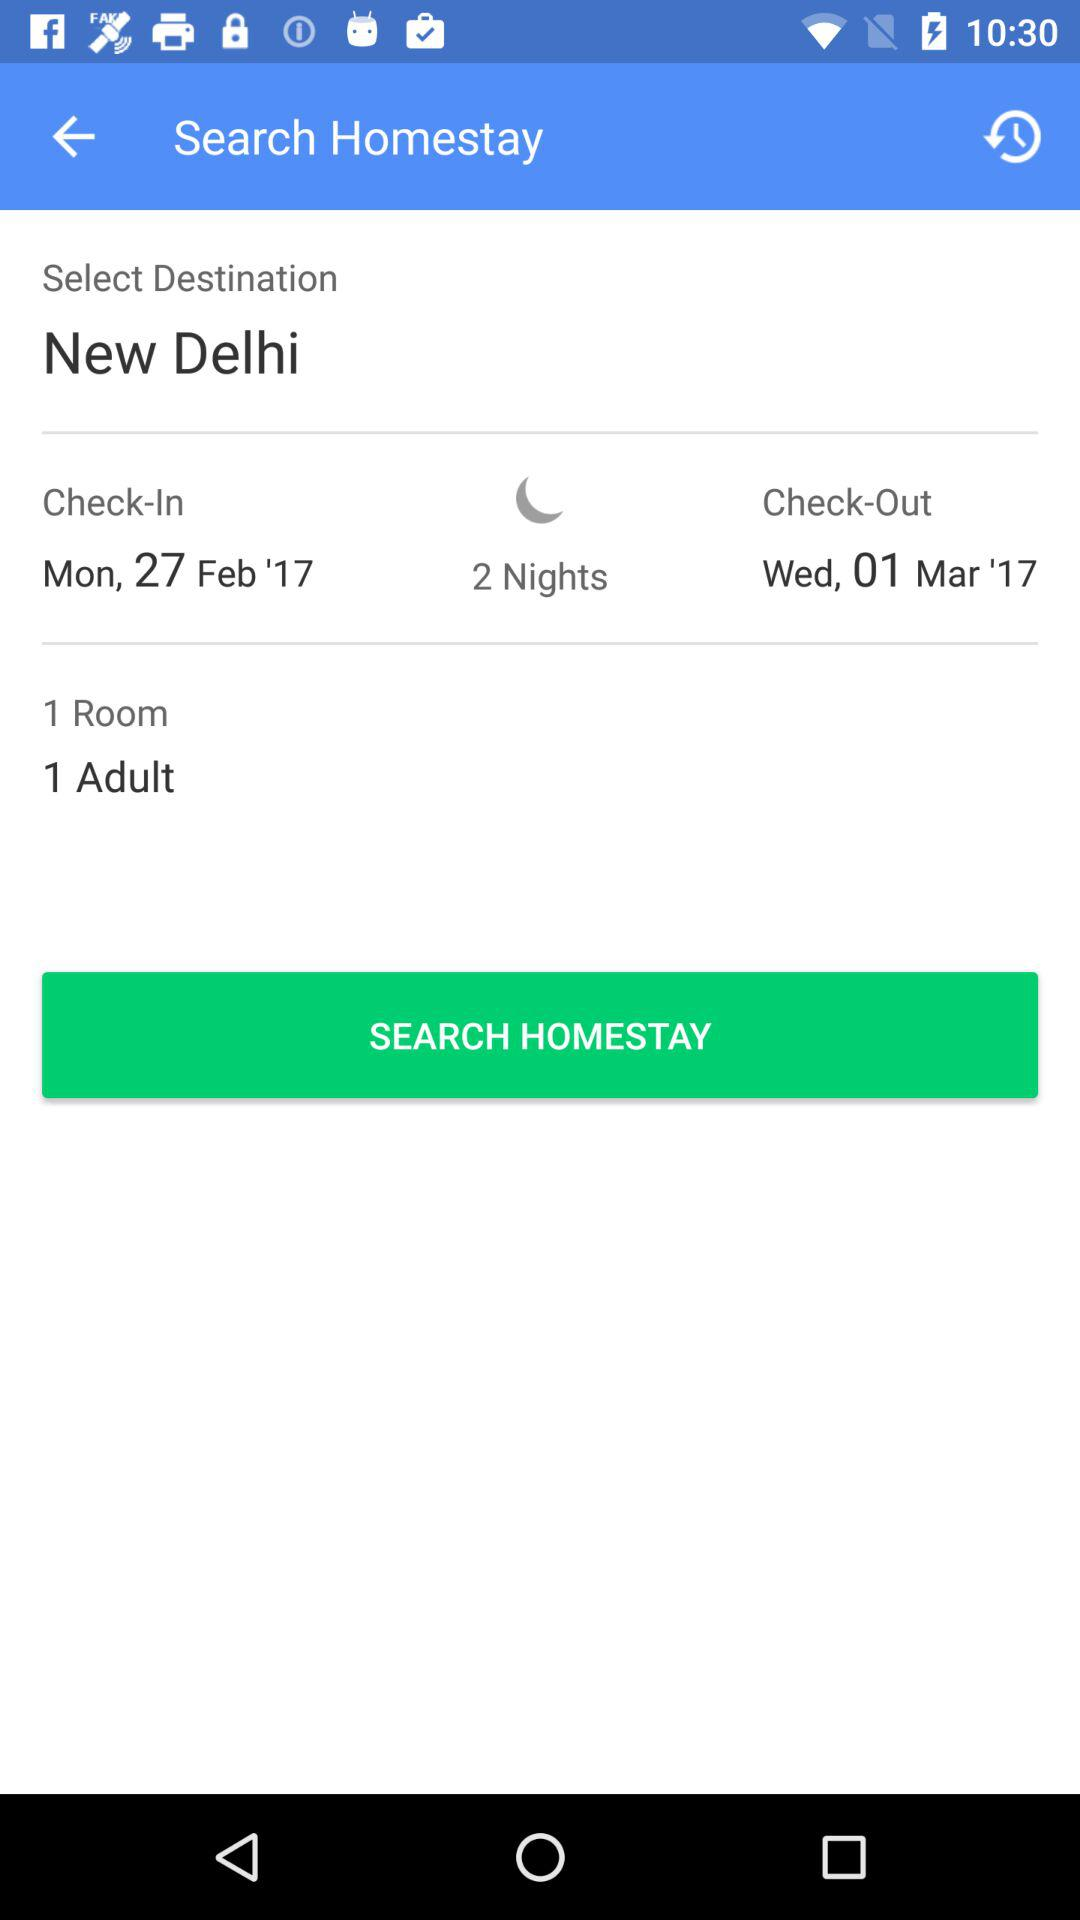When will the check-out be done? The check-out will be done on Wednesday, March 1, 2017. 